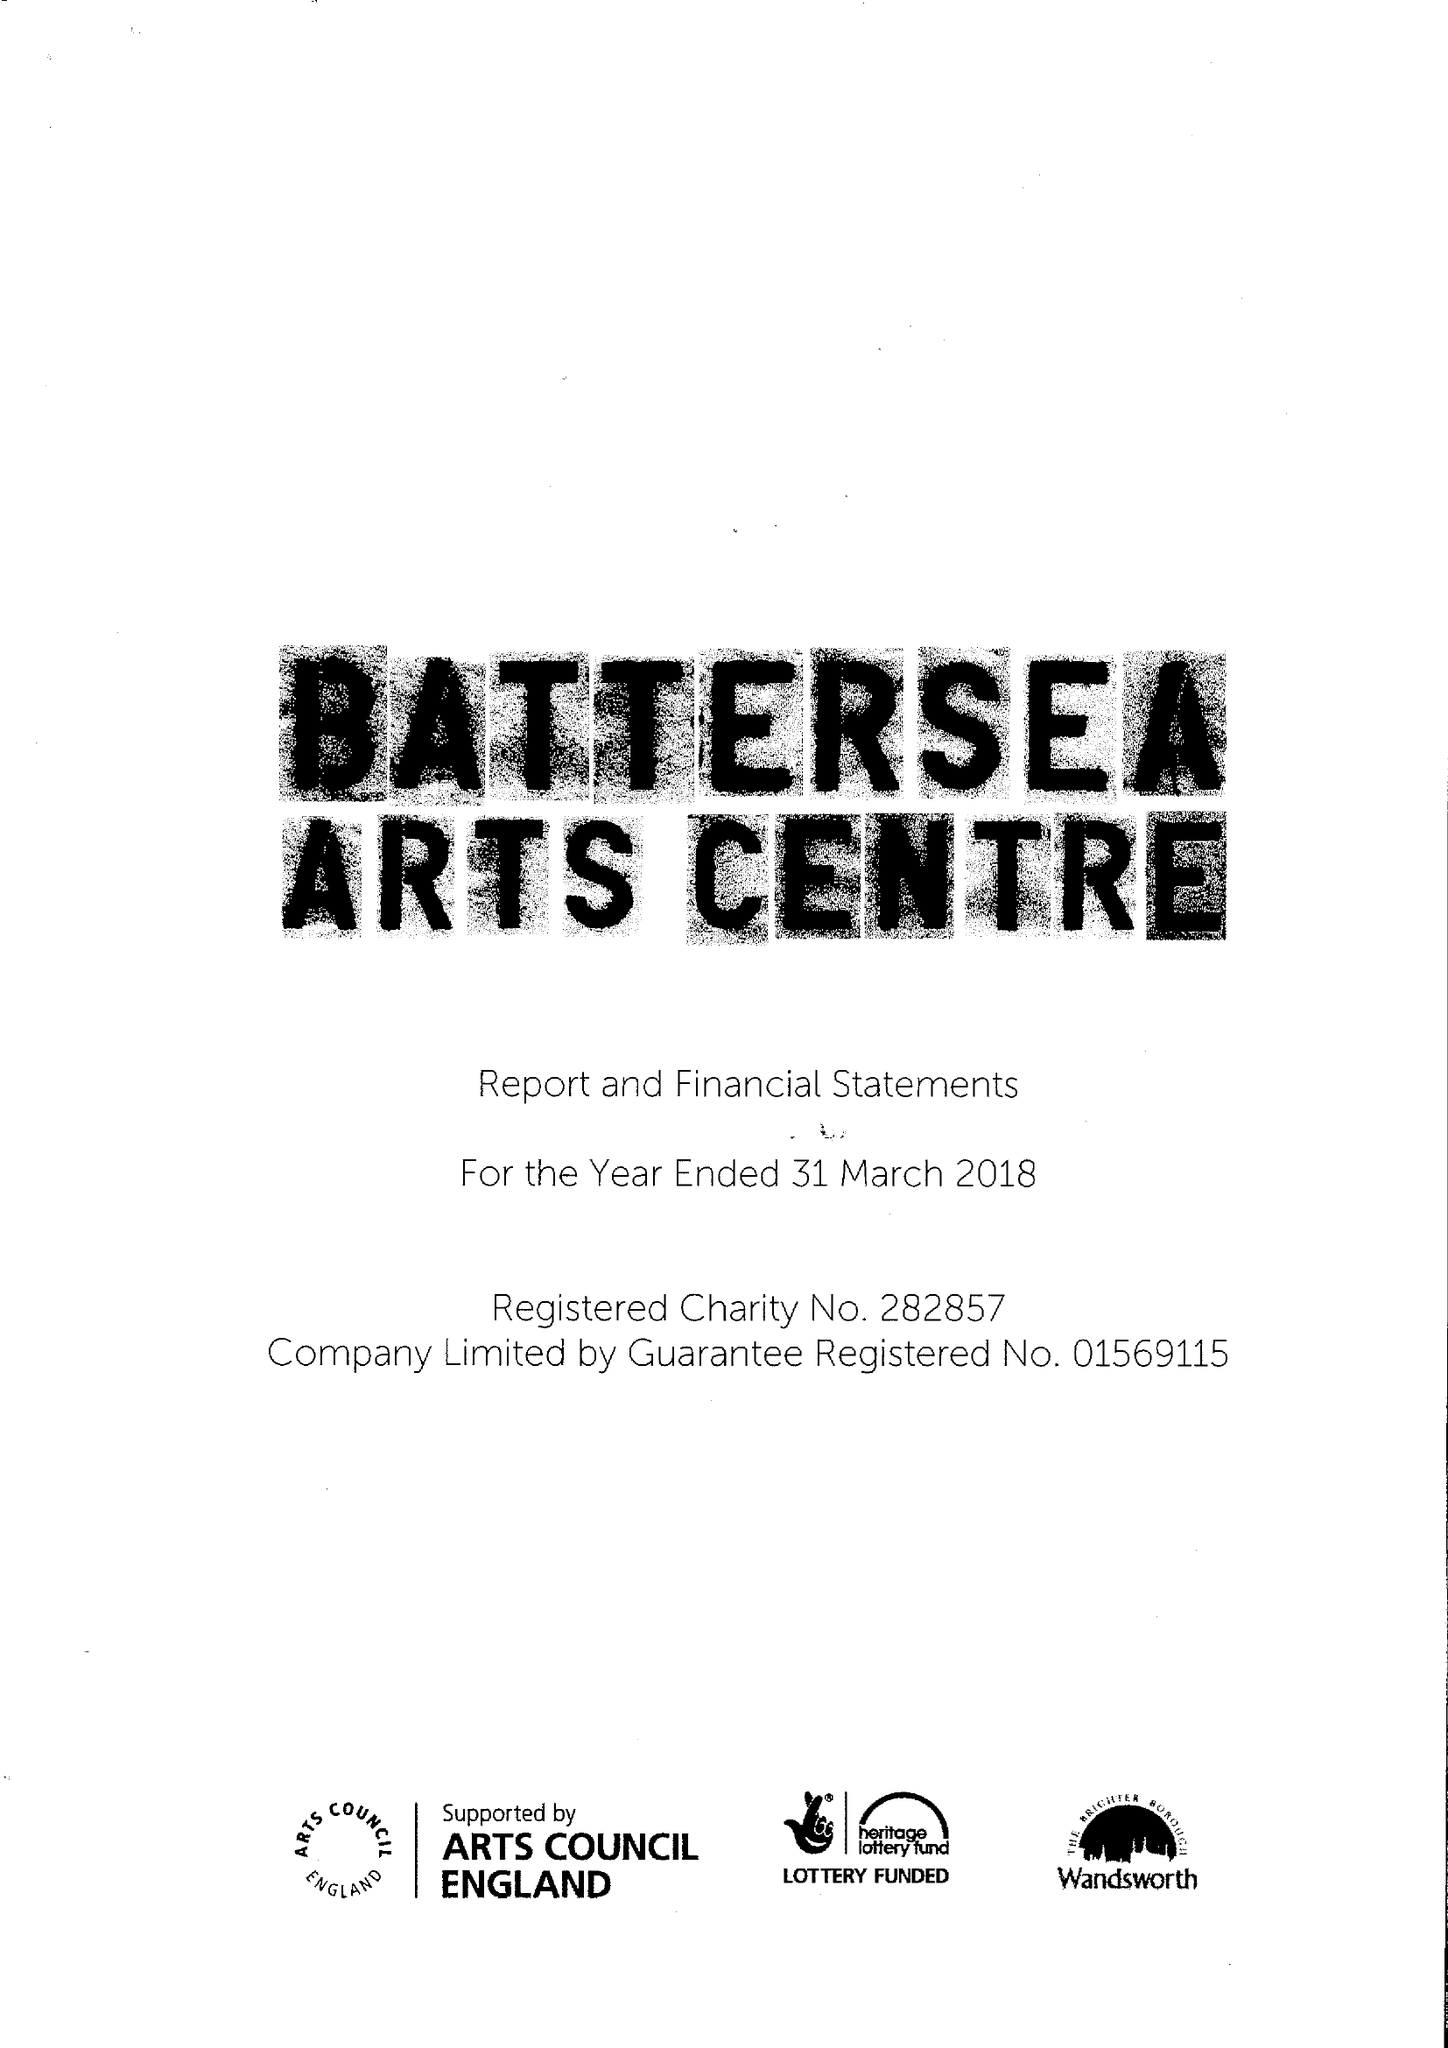What is the value for the address__post_town?
Answer the question using a single word or phrase. LONDON 